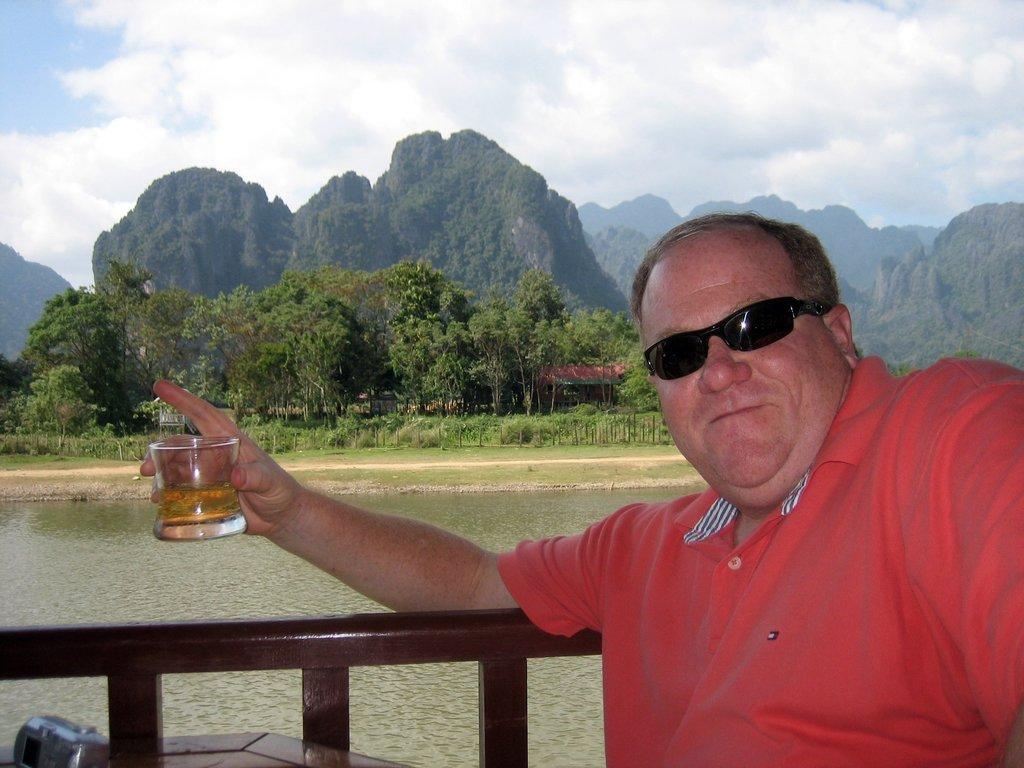Could you give a brief overview of what you see in this image? In this picture we can see a man holding a glass of drink, at the bottom there is water, in the background we can see hills and trees, there is the sky at the top of the picture. 